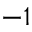Convert formula to latex. <formula><loc_0><loc_0><loc_500><loc_500>- 1</formula> 